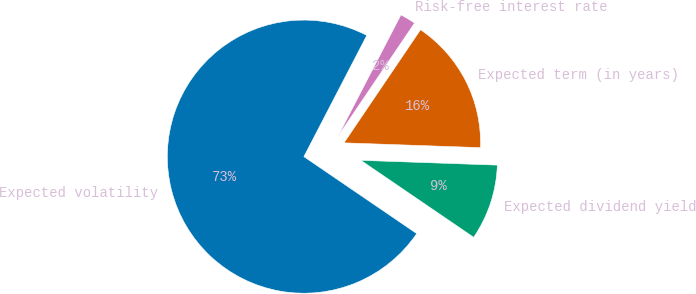Convert chart to OTSL. <chart><loc_0><loc_0><loc_500><loc_500><pie_chart><fcel>Expected volatility<fcel>Expected dividend yield<fcel>Expected term (in years)<fcel>Risk-free interest rate<nl><fcel>73.09%<fcel>8.97%<fcel>16.09%<fcel>1.85%<nl></chart> 